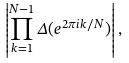Convert formula to latex. <formula><loc_0><loc_0><loc_500><loc_500>\left | \prod _ { k = 1 } ^ { N - 1 } \Delta ( { e ^ { 2 \pi i k / N } } ) \right | ,</formula> 